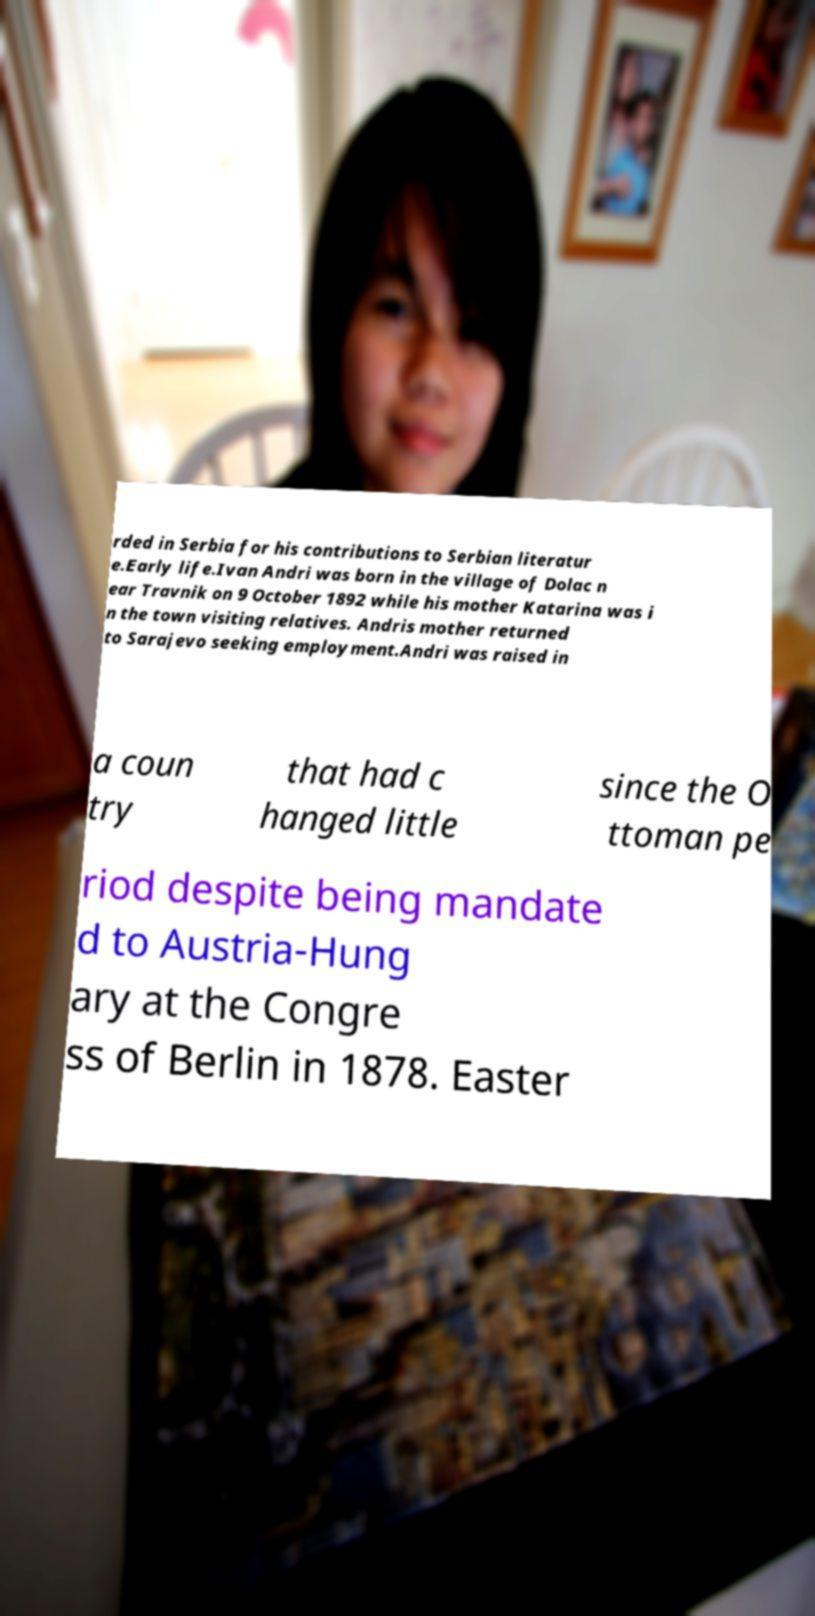I need the written content from this picture converted into text. Can you do that? rded in Serbia for his contributions to Serbian literatur e.Early life.Ivan Andri was born in the village of Dolac n ear Travnik on 9 October 1892 while his mother Katarina was i n the town visiting relatives. Andris mother returned to Sarajevo seeking employment.Andri was raised in a coun try that had c hanged little since the O ttoman pe riod despite being mandate d to Austria-Hung ary at the Congre ss of Berlin in 1878. Easter 